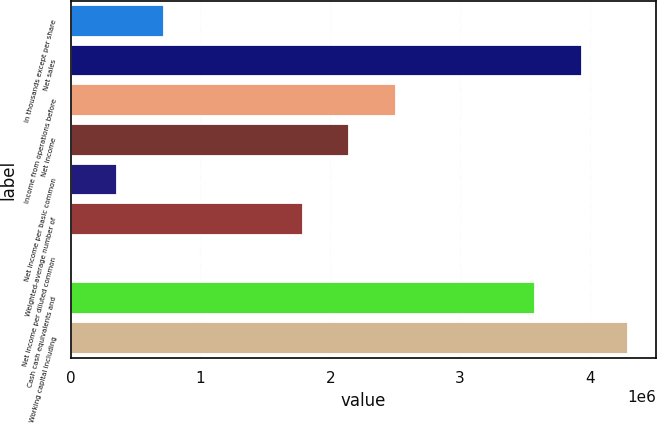Convert chart. <chart><loc_0><loc_0><loc_500><loc_500><bar_chart><fcel>In thousands except per share<fcel>Net sales<fcel>Income from operations before<fcel>Net income<fcel>Net income per basic common<fcel>Weighted-average number of<fcel>Net income per diluted common<fcel>Cash cash equivalents and<fcel>Working capital including<nl><fcel>716025<fcel>3.93812e+06<fcel>2.50608e+06<fcel>2.14807e+06<fcel>358015<fcel>1.79006e+06<fcel>5.2<fcel>3.58011e+06<fcel>4.29613e+06<nl></chart> 